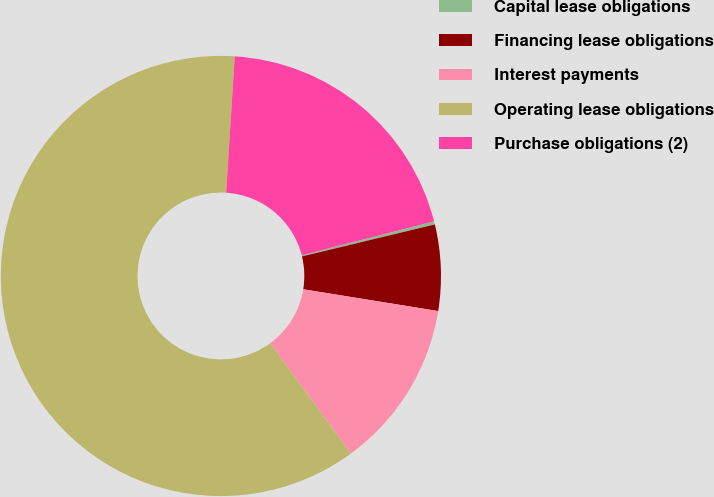<chart> <loc_0><loc_0><loc_500><loc_500><pie_chart><fcel>Capital lease obligations<fcel>Financing lease obligations<fcel>Interest payments<fcel>Operating lease obligations<fcel>Purchase obligations (2)<nl><fcel>0.23%<fcel>6.31%<fcel>12.4%<fcel>61.06%<fcel>20.01%<nl></chart> 